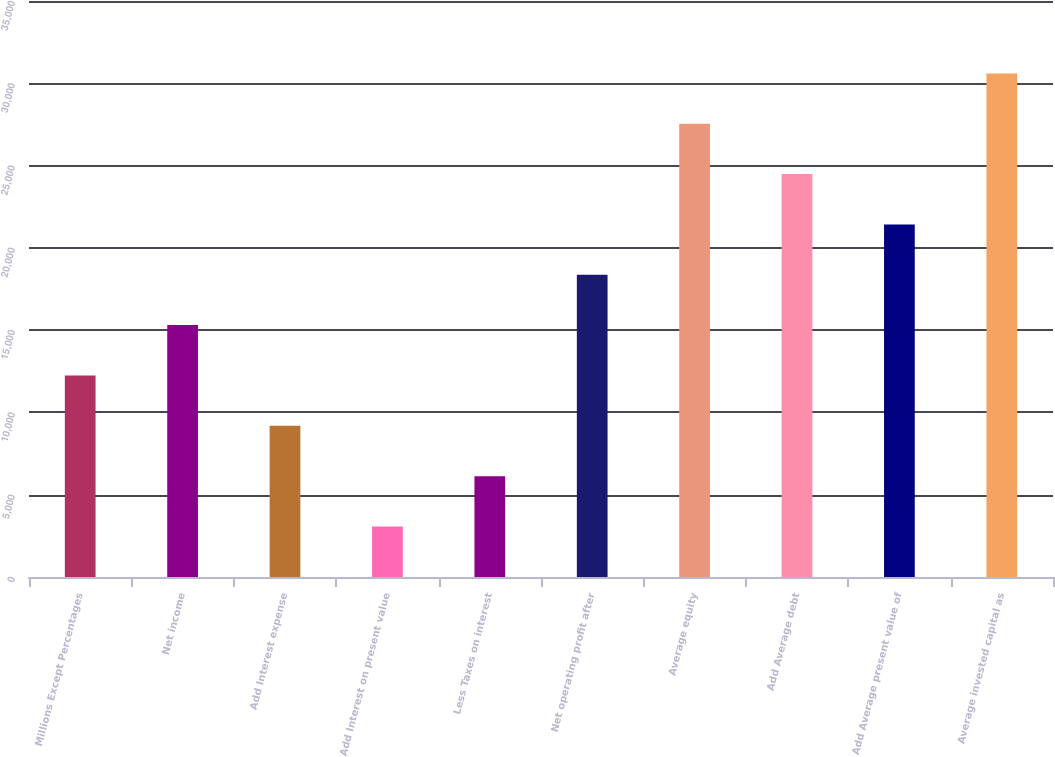<chart> <loc_0><loc_0><loc_500><loc_500><bar_chart><fcel>Millions Except Percentages<fcel>Net income<fcel>Add Interest expense<fcel>Add Interest on present value<fcel>Less Taxes on interest<fcel>Net operating profit after<fcel>Average equity<fcel>Add Average debt<fcel>Add Average present value of<fcel>Average invested capital as<nl><fcel>12246.9<fcel>15305.9<fcel>9187.86<fcel>3069.82<fcel>6128.84<fcel>18364.9<fcel>27542<fcel>24483<fcel>21423.9<fcel>30601<nl></chart> 